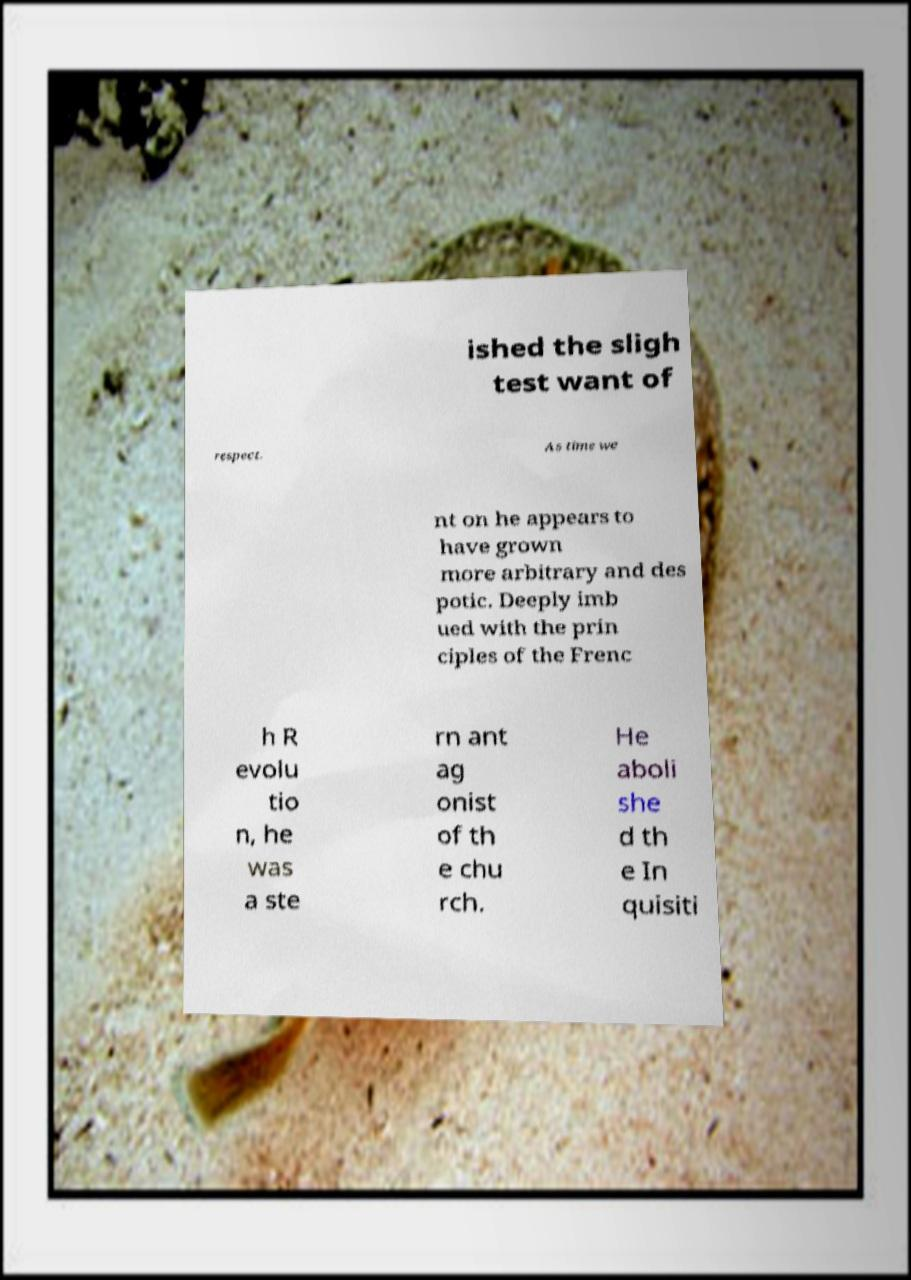Could you extract and type out the text from this image? ished the sligh test want of respect. As time we nt on he appears to have grown more arbitrary and des potic. Deeply imb ued with the prin ciples of the Frenc h R evolu tio n, he was a ste rn ant ag onist of th e chu rch. He aboli she d th e In quisiti 